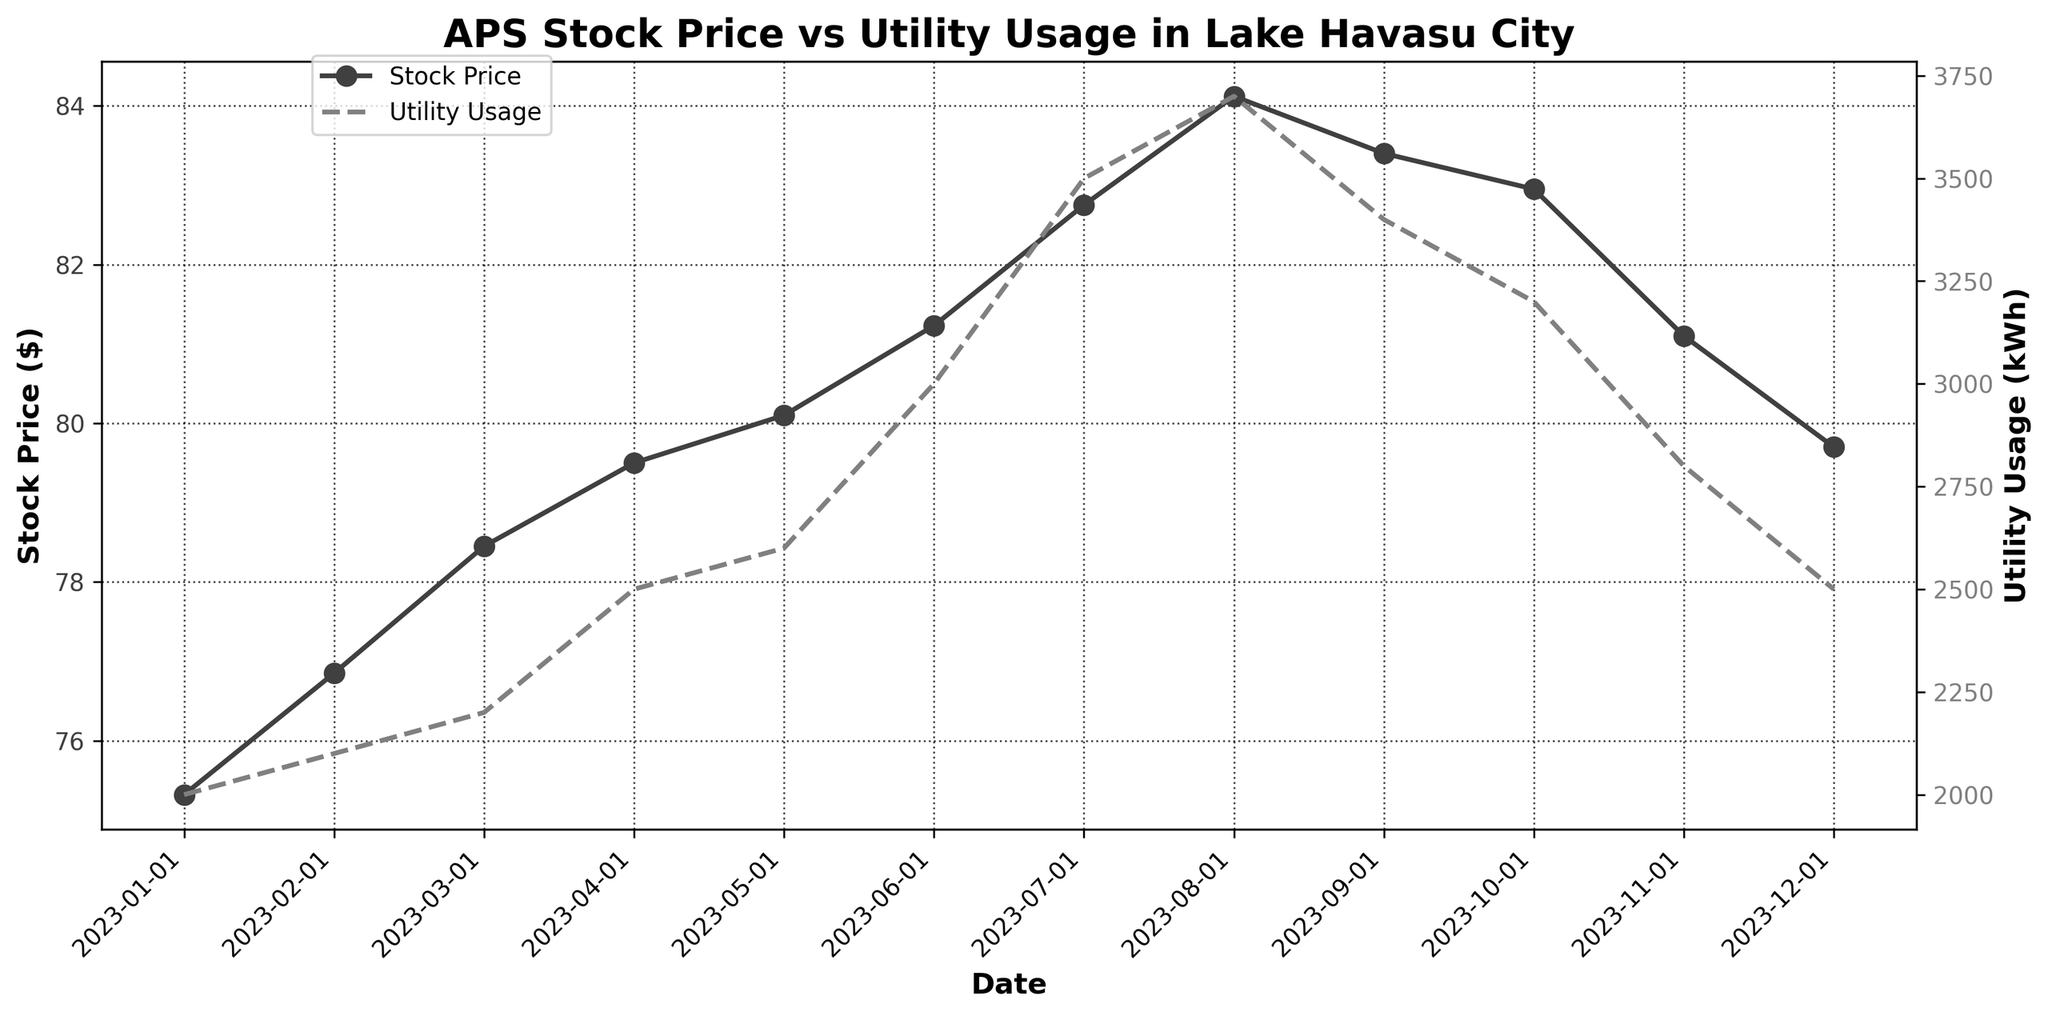When is the peak stock price for APS? The peak stock price can be found by identifying the highest point on the stock price line. In this case, the highest point is in August with a stock price of $84.12.
Answer: August What general trend is observed in the utility usage over the year? To determine the trend in utility usage, observe the utility usage line throughout the year. It generally increases from January to August, peaks in August, and then decreases toward December.
Answer: Increases then decreases What is the relationship between stock price and utility usage? To analyze the relationship, compare the trends in both stock price and utility usage. Both lines increase together until around August and then decrease afterward, suggesting a positive correlation.
Answer: Positive correlation Which month shows the largest increase in stock price compared to the previous month? To find the largest month-over-month increase, calculate the difference in stock prices between consecutive months. The largest increase is between July and August, with a difference of $1.37 ($84.12 - $82.75).
Answer: August How does the utility usage in September compare to that in May? To compare utility usage for September and May, identify the utility usage values for both months: September has 3400 kWh, while May has 2600 kWh. Subtract May's value from September's to find the difference.
Answer: 800 kWh higher What was the stock price in April? Look at the stock price line in the plot and find the stock price value for April. The stock price for April is $79.50.
Answer: $79.50 Which month had the highest utility usage, and what was it? Identify the highest point on the utility usage line. The highest utility usage occurs in August with a value of 3700 kWh.
Answer: August, 3700 kWh Does the stock price show more volatility than utility usage over the year? To determine volatility, assess the variations in the lines. The stock price increases steadily with minor changes, while the utility usage shows larger variations, especially around the peak in August. Therefore, utility usage shows more volatility.
Answer: No What is the difference in stock price between the beginning and the end of the year? Subtract the stock price in January from the stock price in December: $79.70 - $75.32.
Answer: $4.38 In which month does utility usage start to decrease after reaching its peak? Observe the utility usage line to find the month right after the highest peak in August. Utility usage starts to decrease in September.
Answer: September 